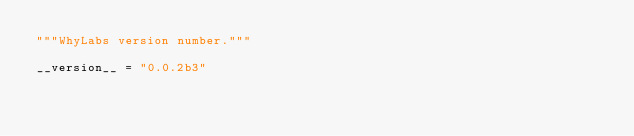Convert code to text. <code><loc_0><loc_0><loc_500><loc_500><_Python_>"""WhyLabs version number."""

__version__ = "0.0.2b3"
</code> 